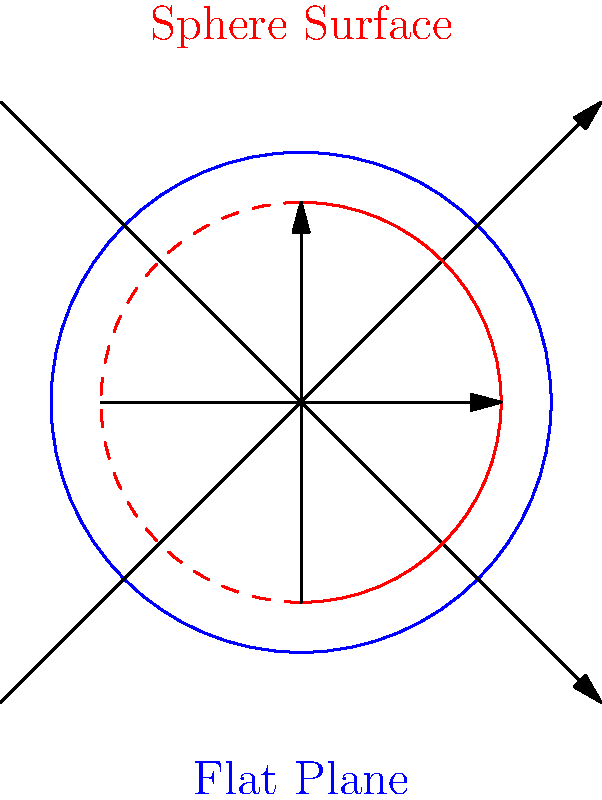In the context of non-Euclidean geometry, how does the area growth of a circle on a sphere's surface differ from that on a flat plane? Relate this concept to the curvature differences experienced in helicopter and commercial airplane flight paths. To understand the difference in area growth between circles on a flat plane and a sphere, let's break it down step-by-step:

1. Flat plane (Euclidean geometry):
   - Area of a circle: $A = \pi r^2$
   - As radius $r$ increases, area grows quadratically

2. Sphere surface (non-Euclidean geometry):
   - Area of a circle on a sphere: $A = 2\pi R^2 (1 - \cos(\frac{r}{R}))$
   - Where $R$ is the sphere's radius and $r$ is the circle's radius
   - As $r$ increases, area growth slows down compared to flat plane

3. Key differences:
   - On a flat plane, area grows indefinitely as radius increases
   - On a sphere, area growth is bounded by the sphere's surface area

4. Relation to flight paths:
   - Helicopters: Often fly at lower altitudes, experiencing less curvature effect
   - Commercial airplanes: Fly at higher altitudes, need to account for Earth's curvature

5. Flight path implications:
   - Helicopters: Shorter distances, minimal curvature correction needed
   - Airplanes: Longer distances, must adjust for Earth's curvature in navigation

6. Military relevance:
   - Accurate navigation crucial for both aircraft types
   - Understanding geometric differences vital for mission planning and execution

This geometric concept illustrates why long-distance flights (like those of commercial airplanes) must account for Earth's curvature, while shorter helicopter flights can often treat the Earth's surface as approximately flat.
Answer: Circle area growth on a sphere is slower and bounded compared to unbounded quadratic growth on a flat plane, affecting long-distance flight paths more than short-distance ones. 